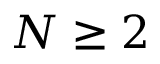<formula> <loc_0><loc_0><loc_500><loc_500>N \geq 2</formula> 